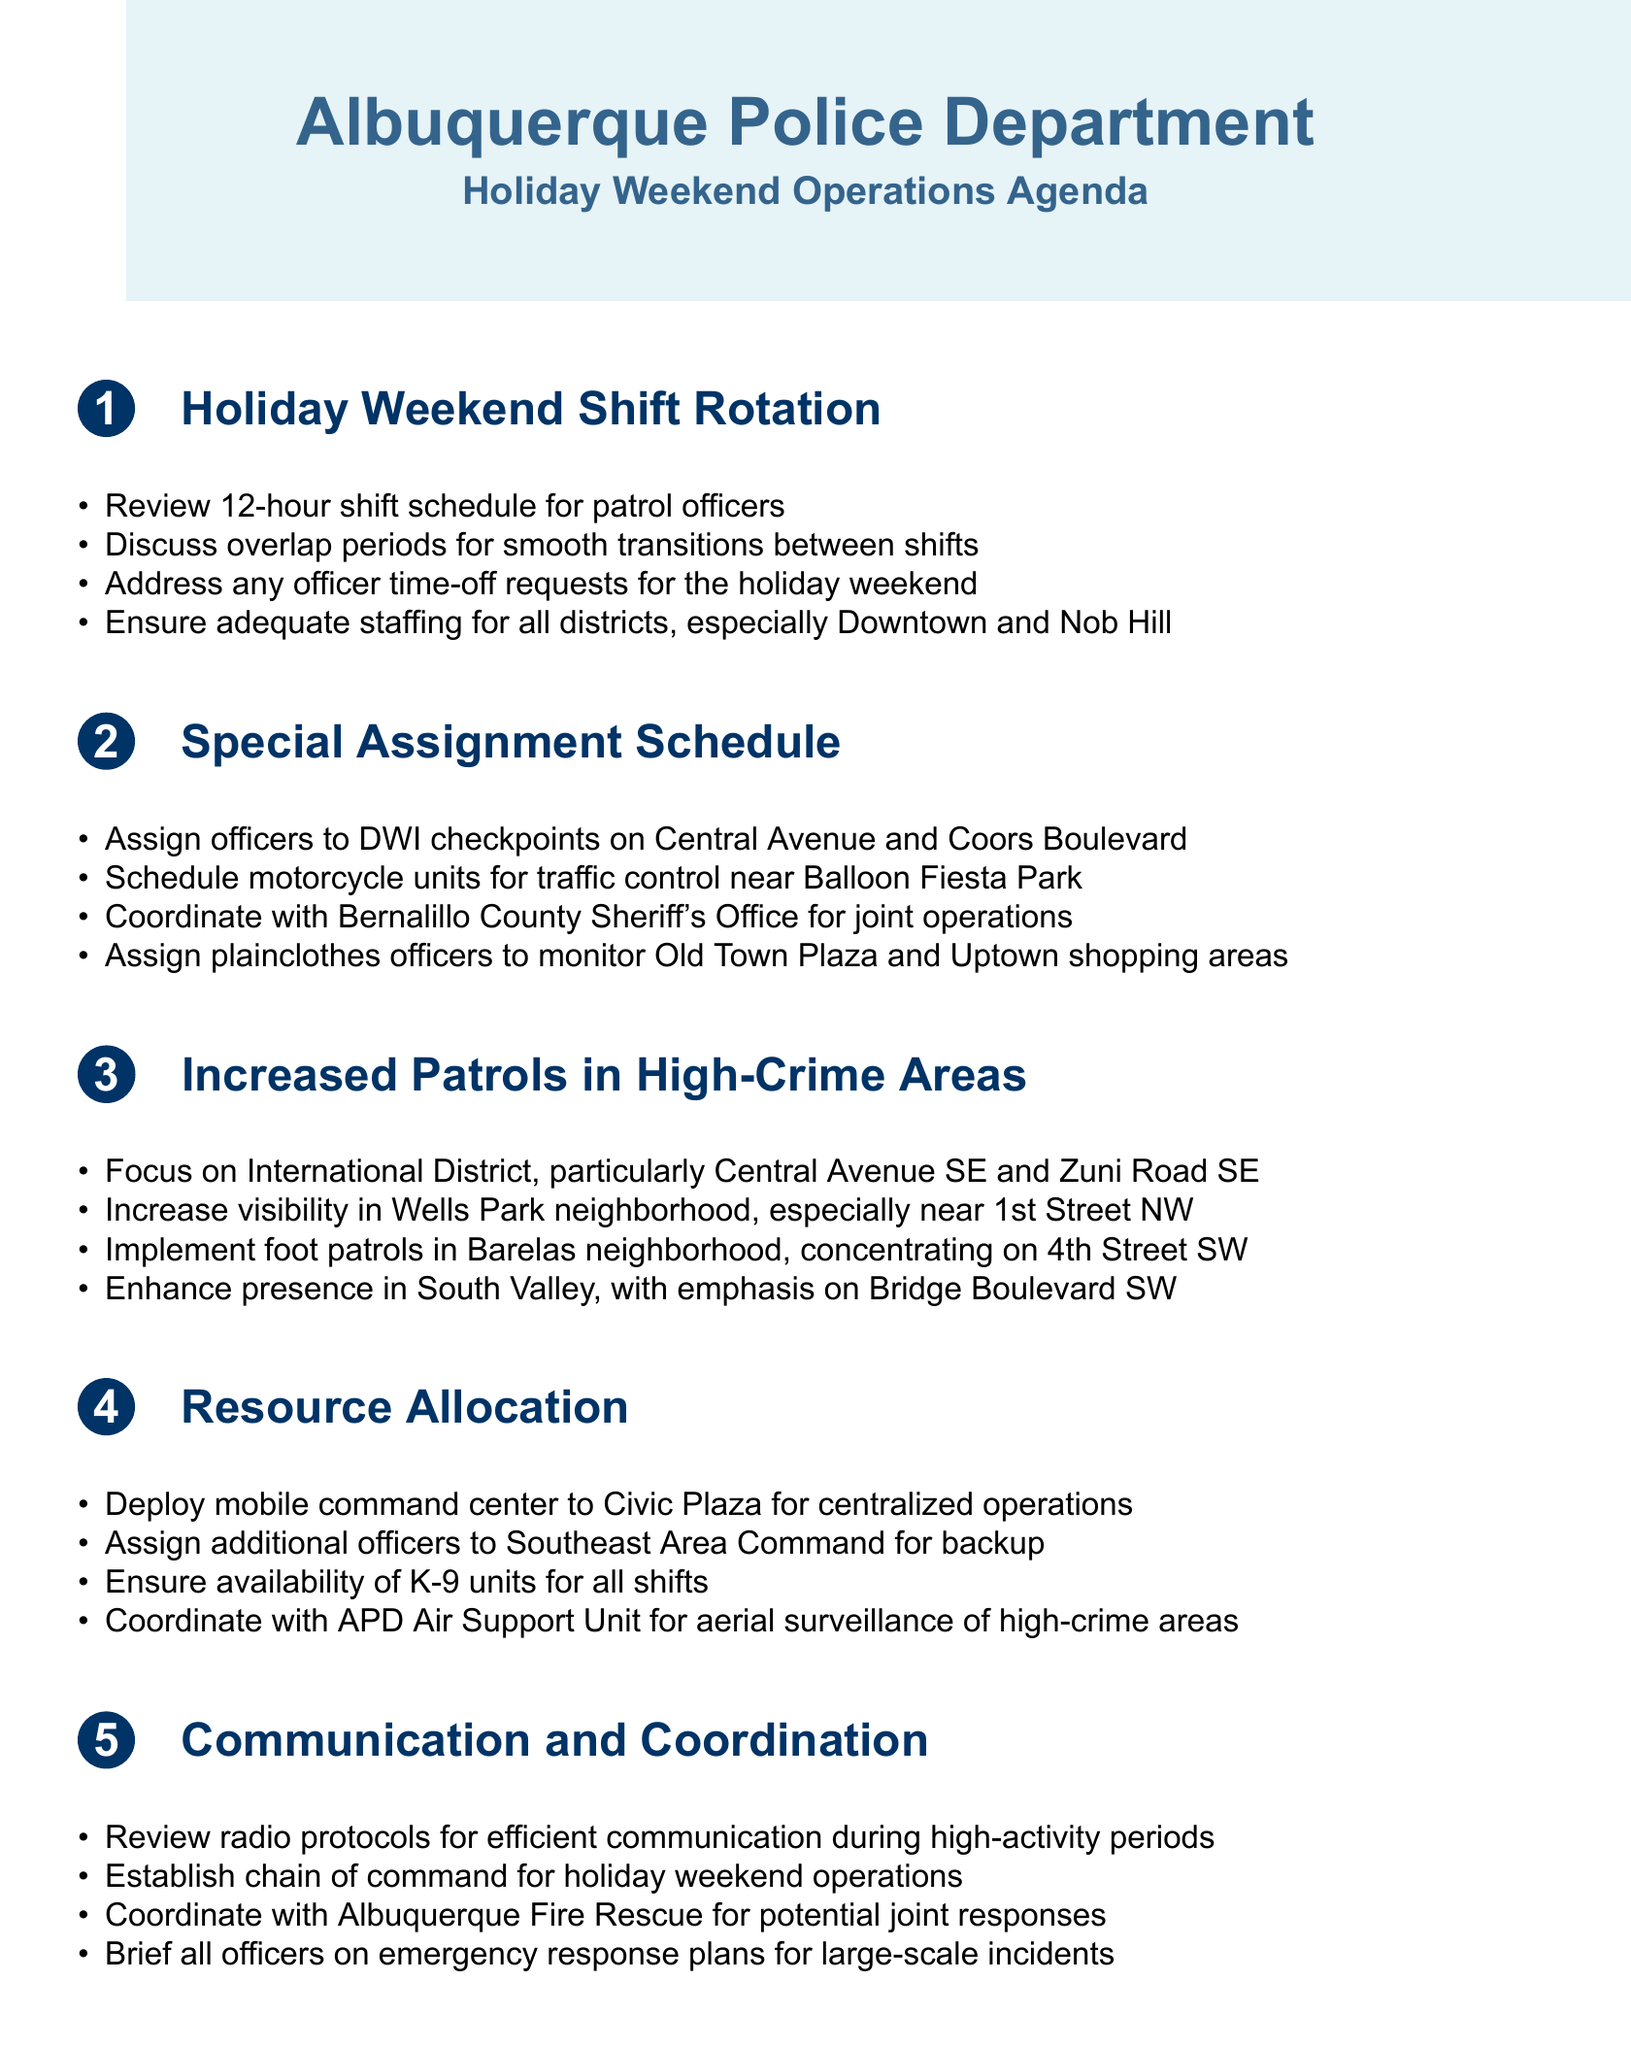What is the main focus of the increased patrols? The increased patrols specifically focus on high-crime areas, especially in the International District.
Answer: International District How many shifts are being reviewed for the holiday weekend? The agenda item mentions reviewing a 12-hour shift schedule, which indicates shifts are focused on that duration.
Answer: 12-hour Where will DWI checkpoints be assigned? DWI checkpoints are assigned on Central Avenue and Coors Boulevard, as stated in the special assignment schedule.
Answer: Central Avenue and Coors Boulevard What neighborhood will foot patrols be concentrated in? The document specifies that foot patrols will concentrate on Barelas neighborhood, particularly 4th Street SW.
Answer: Barelas neighborhood Which command will receive additional officers for backup? The document mentions that additional officers will be assigned to Southeast Area Command for backup purposes.
Answer: Southeast Area Command What is one community engagement initiative mentioned? One of the initiatives listed is to organize a community outreach event at Los Altos Park.
Answer: community outreach event at Los Altos Park How will officers coordinate during high-activity periods? The agenda notes that officers will review radio protocols for efficient communication.
Answer: Review radio protocols What is the emphasis for patrols in the Wells Park neighborhood? Increased visibility is emphasized specifically near 1st Street NW in the Wells Park neighborhood.
Answer: visibility near 1st Street NW What type of unit will be deployed for aerial surveillance? The document states that the APD Air Support Unit will be coordinated for aerial surveillance of high-crime areas.
Answer: APD Air Support Unit What is the purpose of the mobile command center? The mobile command center is deployed to Civic Plaza for centralized operations during the holiday weekend.
Answer: centralized operations 